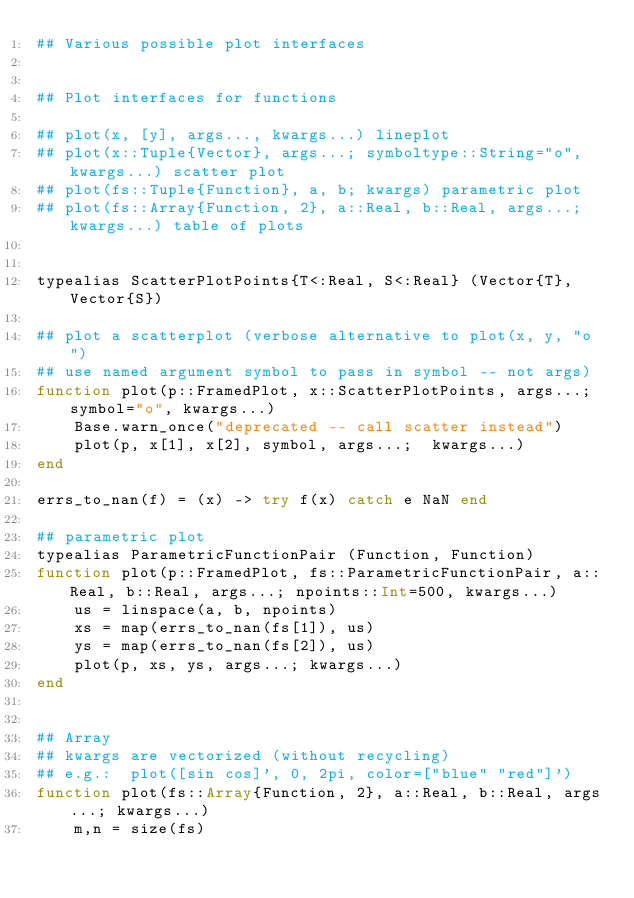Convert code to text. <code><loc_0><loc_0><loc_500><loc_500><_Julia_>## Various possible plot interfaces


## Plot interfaces for functions

## plot(x, [y], args..., kwargs...) lineplot
## plot(x::Tuple{Vector}, args...; symboltype::String="o", kwargs...) scatter plot
## plot(fs::Tuple{Function}, a, b; kwargs) parametric plot
## plot(fs::Array{Function, 2}, a::Real, b::Real, args...; kwargs...) table of plots


typealias ScatterPlotPoints{T<:Real, S<:Real} (Vector{T}, Vector{S})

## plot a scatterplot (verbose alternative to plot(x, y, "o") 
## use named argument symbol to pass in symbol -- not args)
function plot(p::FramedPlot, x::ScatterPlotPoints, args...; symbol="o", kwargs...)
    Base.warn_once("deprecated -- call scatter instead")
    plot(p, x[1], x[2], symbol, args...;  kwargs...)
end

errs_to_nan(f) = (x) -> try f(x) catch e NaN end

## parametric plot
typealias ParametricFunctionPair (Function, Function)
function plot(p::FramedPlot, fs::ParametricFunctionPair, a::Real, b::Real, args...; npoints::Int=500, kwargs...)
    us = linspace(a, b, npoints)
    xs = map(errs_to_nan(fs[1]), us)
    ys = map(errs_to_nan(fs[2]), us)
    plot(p, xs, ys, args...; kwargs...)
end


## Array
## kwargs are vectorized (without recycling)
## e.g.:  plot([sin cos]', 0, 2pi, color=["blue" "red"]') 
function plot(fs::Array{Function, 2}, a::Real, b::Real, args...; kwargs...)
    m,n = size(fs)</code> 